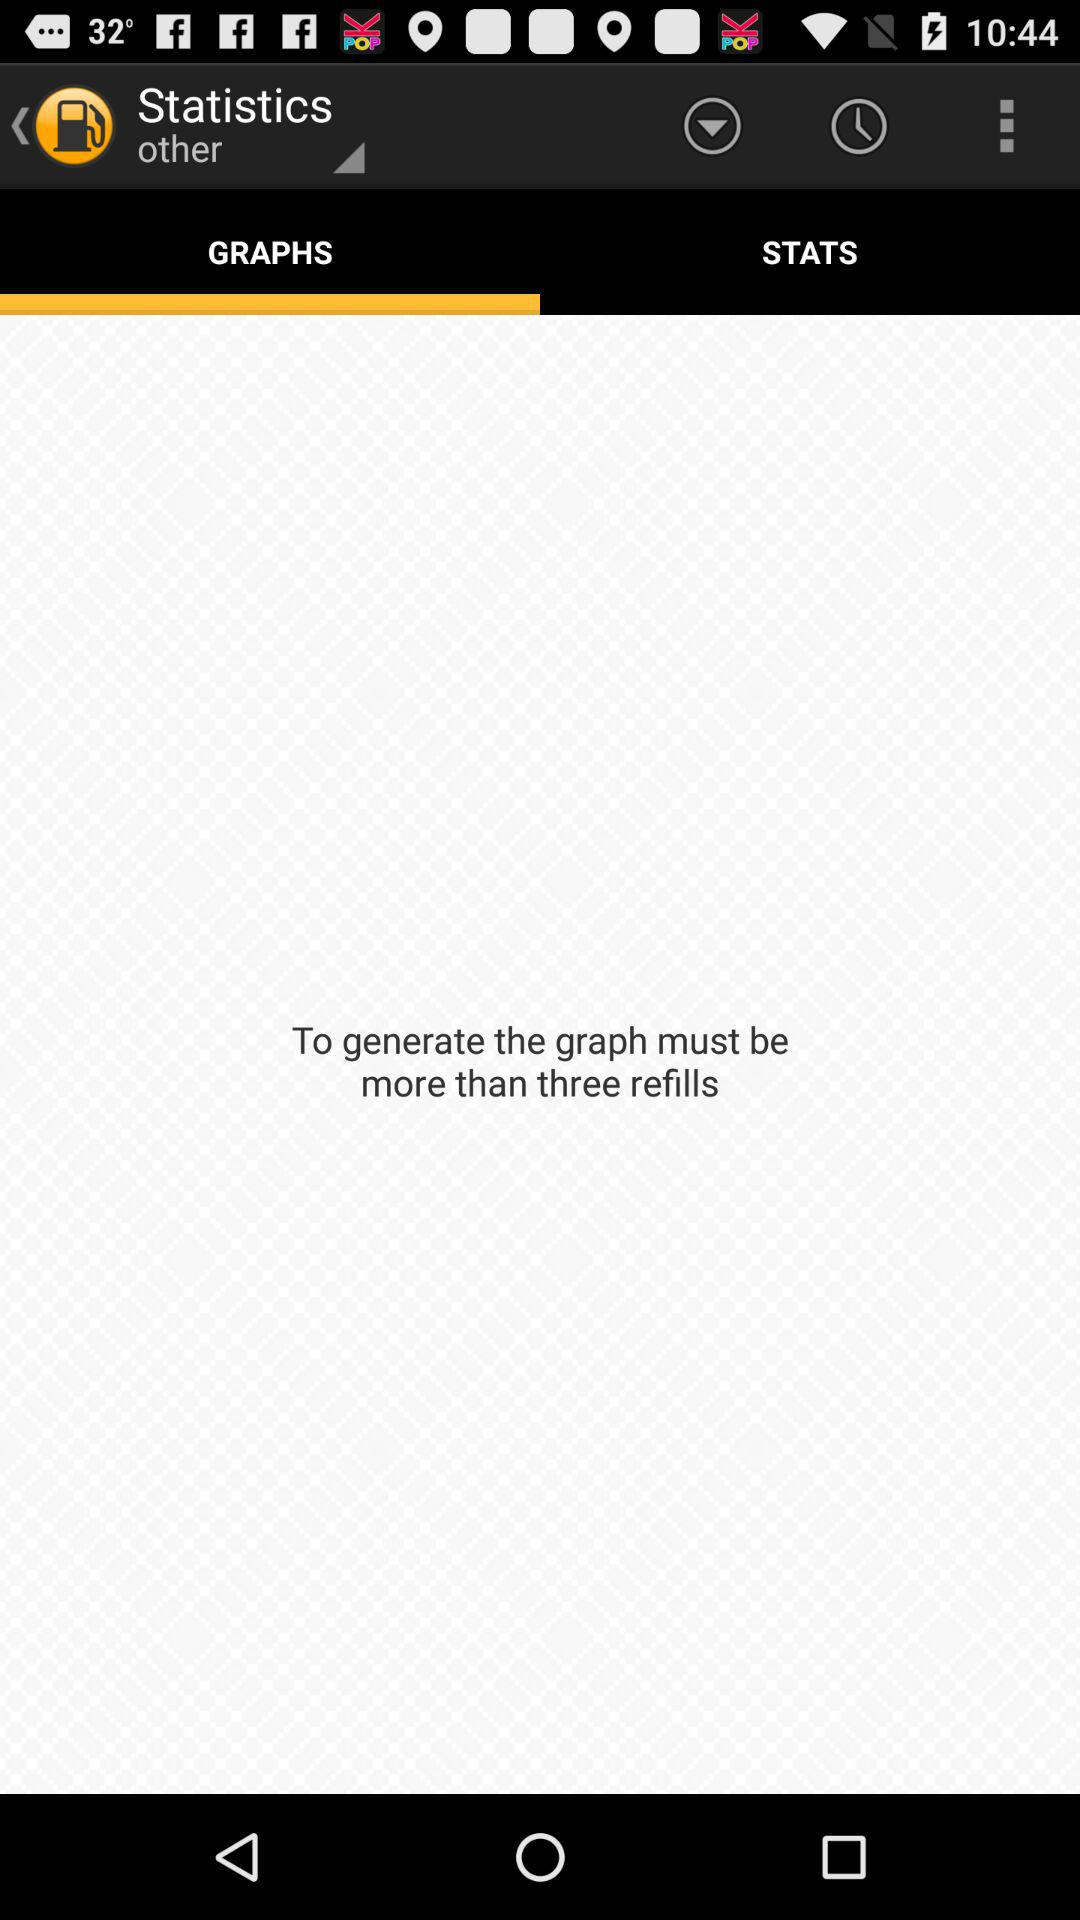Which tab is selected? The selected tab is "GRAPHS". 